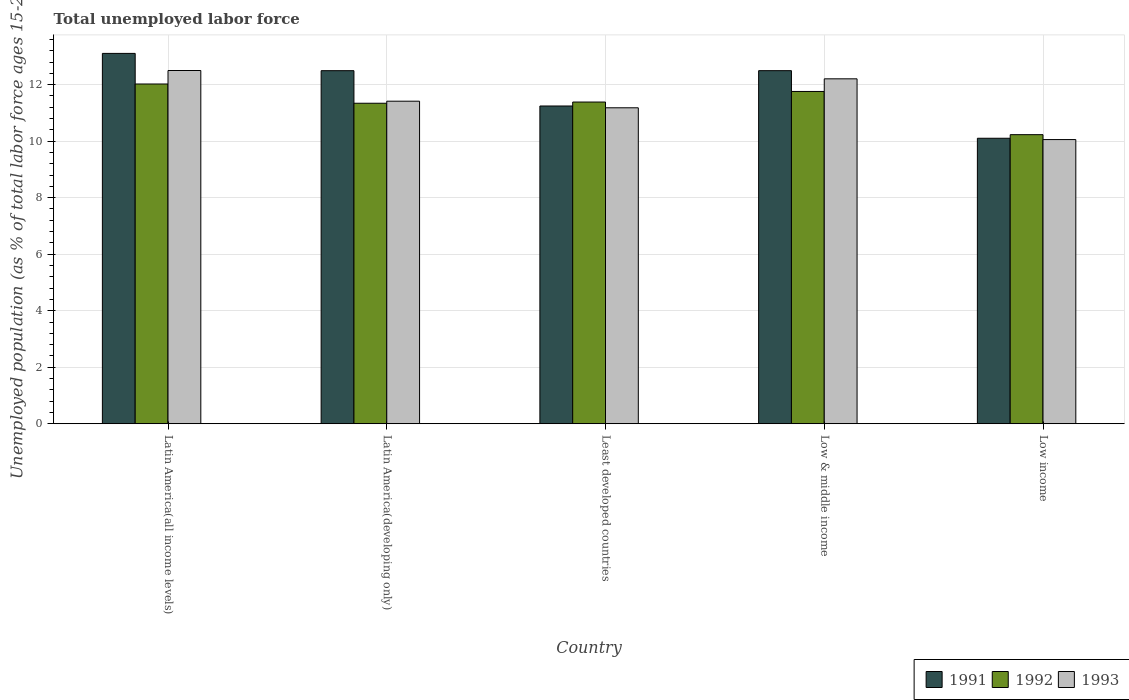How many groups of bars are there?
Keep it short and to the point. 5. Are the number of bars on each tick of the X-axis equal?
Your answer should be very brief. Yes. What is the label of the 1st group of bars from the left?
Provide a succinct answer. Latin America(all income levels). In how many cases, is the number of bars for a given country not equal to the number of legend labels?
Keep it short and to the point. 0. What is the percentage of unemployed population in in 1992 in Latin America(all income levels)?
Keep it short and to the point. 12.02. Across all countries, what is the maximum percentage of unemployed population in in 1991?
Provide a short and direct response. 13.11. Across all countries, what is the minimum percentage of unemployed population in in 1992?
Provide a succinct answer. 10.23. In which country was the percentage of unemployed population in in 1992 maximum?
Your response must be concise. Latin America(all income levels). What is the total percentage of unemployed population in in 1991 in the graph?
Ensure brevity in your answer.  59.45. What is the difference between the percentage of unemployed population in in 1993 in Latin America(all income levels) and that in Least developed countries?
Your response must be concise. 1.32. What is the difference between the percentage of unemployed population in in 1992 in Least developed countries and the percentage of unemployed population in in 1991 in Latin America(developing only)?
Your answer should be compact. -1.11. What is the average percentage of unemployed population in in 1992 per country?
Provide a succinct answer. 11.35. What is the difference between the percentage of unemployed population in of/in 1993 and percentage of unemployed population in of/in 1992 in Latin America(developing only)?
Your answer should be very brief. 0.07. What is the ratio of the percentage of unemployed population in in 1992 in Low & middle income to that in Low income?
Ensure brevity in your answer.  1.15. Is the percentage of unemployed population in in 1993 in Low & middle income less than that in Low income?
Provide a short and direct response. No. What is the difference between the highest and the second highest percentage of unemployed population in in 1992?
Offer a terse response. -0.37. What is the difference between the highest and the lowest percentage of unemployed population in in 1992?
Provide a succinct answer. 1.79. In how many countries, is the percentage of unemployed population in in 1991 greater than the average percentage of unemployed population in in 1991 taken over all countries?
Offer a very short reply. 3. Is the sum of the percentage of unemployed population in in 1993 in Latin America(all income levels) and Low income greater than the maximum percentage of unemployed population in in 1992 across all countries?
Your answer should be very brief. Yes. What does the 3rd bar from the left in Least developed countries represents?
Provide a succinct answer. 1993. What does the 3rd bar from the right in Low & middle income represents?
Provide a short and direct response. 1991. Is it the case that in every country, the sum of the percentage of unemployed population in in 1991 and percentage of unemployed population in in 1993 is greater than the percentage of unemployed population in in 1992?
Keep it short and to the point. Yes. Are all the bars in the graph horizontal?
Ensure brevity in your answer.  No. How many countries are there in the graph?
Your response must be concise. 5. What is the difference between two consecutive major ticks on the Y-axis?
Provide a succinct answer. 2. Are the values on the major ticks of Y-axis written in scientific E-notation?
Offer a very short reply. No. Does the graph contain any zero values?
Your response must be concise. No. Where does the legend appear in the graph?
Ensure brevity in your answer.  Bottom right. What is the title of the graph?
Ensure brevity in your answer.  Total unemployed labor force. What is the label or title of the Y-axis?
Give a very brief answer. Unemployed population (as % of total labor force ages 15-24). What is the Unemployed population (as % of total labor force ages 15-24) in 1991 in Latin America(all income levels)?
Offer a terse response. 13.11. What is the Unemployed population (as % of total labor force ages 15-24) in 1992 in Latin America(all income levels)?
Offer a very short reply. 12.02. What is the Unemployed population (as % of total labor force ages 15-24) of 1993 in Latin America(all income levels)?
Your answer should be very brief. 12.5. What is the Unemployed population (as % of total labor force ages 15-24) in 1991 in Latin America(developing only)?
Offer a terse response. 12.5. What is the Unemployed population (as % of total labor force ages 15-24) of 1992 in Latin America(developing only)?
Your answer should be compact. 11.34. What is the Unemployed population (as % of total labor force ages 15-24) in 1993 in Latin America(developing only)?
Keep it short and to the point. 11.42. What is the Unemployed population (as % of total labor force ages 15-24) in 1991 in Least developed countries?
Offer a very short reply. 11.25. What is the Unemployed population (as % of total labor force ages 15-24) in 1992 in Least developed countries?
Make the answer very short. 11.39. What is the Unemployed population (as % of total labor force ages 15-24) of 1993 in Least developed countries?
Offer a very short reply. 11.18. What is the Unemployed population (as % of total labor force ages 15-24) in 1991 in Low & middle income?
Provide a succinct answer. 12.5. What is the Unemployed population (as % of total labor force ages 15-24) in 1992 in Low & middle income?
Offer a very short reply. 11.76. What is the Unemployed population (as % of total labor force ages 15-24) of 1993 in Low & middle income?
Keep it short and to the point. 12.21. What is the Unemployed population (as % of total labor force ages 15-24) of 1991 in Low income?
Ensure brevity in your answer.  10.1. What is the Unemployed population (as % of total labor force ages 15-24) of 1992 in Low income?
Ensure brevity in your answer.  10.23. What is the Unemployed population (as % of total labor force ages 15-24) of 1993 in Low income?
Offer a very short reply. 10.06. Across all countries, what is the maximum Unemployed population (as % of total labor force ages 15-24) of 1991?
Make the answer very short. 13.11. Across all countries, what is the maximum Unemployed population (as % of total labor force ages 15-24) in 1992?
Keep it short and to the point. 12.02. Across all countries, what is the maximum Unemployed population (as % of total labor force ages 15-24) of 1993?
Make the answer very short. 12.5. Across all countries, what is the minimum Unemployed population (as % of total labor force ages 15-24) in 1991?
Your response must be concise. 10.1. Across all countries, what is the minimum Unemployed population (as % of total labor force ages 15-24) in 1992?
Give a very brief answer. 10.23. Across all countries, what is the minimum Unemployed population (as % of total labor force ages 15-24) of 1993?
Your answer should be very brief. 10.06. What is the total Unemployed population (as % of total labor force ages 15-24) of 1991 in the graph?
Your answer should be compact. 59.45. What is the total Unemployed population (as % of total labor force ages 15-24) in 1992 in the graph?
Give a very brief answer. 56.74. What is the total Unemployed population (as % of total labor force ages 15-24) of 1993 in the graph?
Your answer should be compact. 57.36. What is the difference between the Unemployed population (as % of total labor force ages 15-24) of 1991 in Latin America(all income levels) and that in Latin America(developing only)?
Your answer should be very brief. 0.61. What is the difference between the Unemployed population (as % of total labor force ages 15-24) in 1992 in Latin America(all income levels) and that in Latin America(developing only)?
Offer a very short reply. 0.68. What is the difference between the Unemployed population (as % of total labor force ages 15-24) of 1993 in Latin America(all income levels) and that in Latin America(developing only)?
Make the answer very short. 1.09. What is the difference between the Unemployed population (as % of total labor force ages 15-24) in 1991 in Latin America(all income levels) and that in Least developed countries?
Offer a very short reply. 1.86. What is the difference between the Unemployed population (as % of total labor force ages 15-24) in 1992 in Latin America(all income levels) and that in Least developed countries?
Your answer should be very brief. 0.64. What is the difference between the Unemployed population (as % of total labor force ages 15-24) in 1993 in Latin America(all income levels) and that in Least developed countries?
Provide a succinct answer. 1.32. What is the difference between the Unemployed population (as % of total labor force ages 15-24) of 1991 in Latin America(all income levels) and that in Low & middle income?
Provide a short and direct response. 0.61. What is the difference between the Unemployed population (as % of total labor force ages 15-24) of 1992 in Latin America(all income levels) and that in Low & middle income?
Your response must be concise. 0.26. What is the difference between the Unemployed population (as % of total labor force ages 15-24) in 1993 in Latin America(all income levels) and that in Low & middle income?
Ensure brevity in your answer.  0.29. What is the difference between the Unemployed population (as % of total labor force ages 15-24) in 1991 in Latin America(all income levels) and that in Low income?
Your answer should be very brief. 3. What is the difference between the Unemployed population (as % of total labor force ages 15-24) of 1992 in Latin America(all income levels) and that in Low income?
Make the answer very short. 1.79. What is the difference between the Unemployed population (as % of total labor force ages 15-24) of 1993 in Latin America(all income levels) and that in Low income?
Keep it short and to the point. 2.44. What is the difference between the Unemployed population (as % of total labor force ages 15-24) in 1991 in Latin America(developing only) and that in Least developed countries?
Offer a very short reply. 1.25. What is the difference between the Unemployed population (as % of total labor force ages 15-24) in 1992 in Latin America(developing only) and that in Least developed countries?
Offer a terse response. -0.04. What is the difference between the Unemployed population (as % of total labor force ages 15-24) in 1993 in Latin America(developing only) and that in Least developed countries?
Keep it short and to the point. 0.23. What is the difference between the Unemployed population (as % of total labor force ages 15-24) of 1991 in Latin America(developing only) and that in Low & middle income?
Offer a terse response. -0. What is the difference between the Unemployed population (as % of total labor force ages 15-24) of 1992 in Latin America(developing only) and that in Low & middle income?
Provide a succinct answer. -0.42. What is the difference between the Unemployed population (as % of total labor force ages 15-24) in 1993 in Latin America(developing only) and that in Low & middle income?
Give a very brief answer. -0.79. What is the difference between the Unemployed population (as % of total labor force ages 15-24) of 1991 in Latin America(developing only) and that in Low income?
Give a very brief answer. 2.39. What is the difference between the Unemployed population (as % of total labor force ages 15-24) of 1992 in Latin America(developing only) and that in Low income?
Keep it short and to the point. 1.11. What is the difference between the Unemployed population (as % of total labor force ages 15-24) of 1993 in Latin America(developing only) and that in Low income?
Ensure brevity in your answer.  1.36. What is the difference between the Unemployed population (as % of total labor force ages 15-24) of 1991 in Least developed countries and that in Low & middle income?
Offer a terse response. -1.25. What is the difference between the Unemployed population (as % of total labor force ages 15-24) in 1992 in Least developed countries and that in Low & middle income?
Your answer should be very brief. -0.37. What is the difference between the Unemployed population (as % of total labor force ages 15-24) in 1993 in Least developed countries and that in Low & middle income?
Offer a very short reply. -1.03. What is the difference between the Unemployed population (as % of total labor force ages 15-24) in 1991 in Least developed countries and that in Low income?
Provide a succinct answer. 1.14. What is the difference between the Unemployed population (as % of total labor force ages 15-24) of 1992 in Least developed countries and that in Low income?
Offer a very short reply. 1.15. What is the difference between the Unemployed population (as % of total labor force ages 15-24) in 1993 in Least developed countries and that in Low income?
Offer a terse response. 1.12. What is the difference between the Unemployed population (as % of total labor force ages 15-24) of 1991 in Low & middle income and that in Low income?
Offer a very short reply. 2.39. What is the difference between the Unemployed population (as % of total labor force ages 15-24) of 1992 in Low & middle income and that in Low income?
Keep it short and to the point. 1.53. What is the difference between the Unemployed population (as % of total labor force ages 15-24) in 1993 in Low & middle income and that in Low income?
Your answer should be very brief. 2.15. What is the difference between the Unemployed population (as % of total labor force ages 15-24) of 1991 in Latin America(all income levels) and the Unemployed population (as % of total labor force ages 15-24) of 1992 in Latin America(developing only)?
Provide a short and direct response. 1.76. What is the difference between the Unemployed population (as % of total labor force ages 15-24) of 1991 in Latin America(all income levels) and the Unemployed population (as % of total labor force ages 15-24) of 1993 in Latin America(developing only)?
Keep it short and to the point. 1.69. What is the difference between the Unemployed population (as % of total labor force ages 15-24) of 1992 in Latin America(all income levels) and the Unemployed population (as % of total labor force ages 15-24) of 1993 in Latin America(developing only)?
Keep it short and to the point. 0.61. What is the difference between the Unemployed population (as % of total labor force ages 15-24) in 1991 in Latin America(all income levels) and the Unemployed population (as % of total labor force ages 15-24) in 1992 in Least developed countries?
Your response must be concise. 1.72. What is the difference between the Unemployed population (as % of total labor force ages 15-24) in 1991 in Latin America(all income levels) and the Unemployed population (as % of total labor force ages 15-24) in 1993 in Least developed countries?
Make the answer very short. 1.93. What is the difference between the Unemployed population (as % of total labor force ages 15-24) of 1992 in Latin America(all income levels) and the Unemployed population (as % of total labor force ages 15-24) of 1993 in Least developed countries?
Your answer should be very brief. 0.84. What is the difference between the Unemployed population (as % of total labor force ages 15-24) of 1991 in Latin America(all income levels) and the Unemployed population (as % of total labor force ages 15-24) of 1992 in Low & middle income?
Ensure brevity in your answer.  1.35. What is the difference between the Unemployed population (as % of total labor force ages 15-24) in 1991 in Latin America(all income levels) and the Unemployed population (as % of total labor force ages 15-24) in 1993 in Low & middle income?
Provide a short and direct response. 0.9. What is the difference between the Unemployed population (as % of total labor force ages 15-24) in 1992 in Latin America(all income levels) and the Unemployed population (as % of total labor force ages 15-24) in 1993 in Low & middle income?
Make the answer very short. -0.18. What is the difference between the Unemployed population (as % of total labor force ages 15-24) of 1991 in Latin America(all income levels) and the Unemployed population (as % of total labor force ages 15-24) of 1992 in Low income?
Give a very brief answer. 2.88. What is the difference between the Unemployed population (as % of total labor force ages 15-24) in 1991 in Latin America(all income levels) and the Unemployed population (as % of total labor force ages 15-24) in 1993 in Low income?
Offer a very short reply. 3.05. What is the difference between the Unemployed population (as % of total labor force ages 15-24) in 1992 in Latin America(all income levels) and the Unemployed population (as % of total labor force ages 15-24) in 1993 in Low income?
Your answer should be compact. 1.97. What is the difference between the Unemployed population (as % of total labor force ages 15-24) in 1991 in Latin America(developing only) and the Unemployed population (as % of total labor force ages 15-24) in 1992 in Least developed countries?
Ensure brevity in your answer.  1.11. What is the difference between the Unemployed population (as % of total labor force ages 15-24) in 1991 in Latin America(developing only) and the Unemployed population (as % of total labor force ages 15-24) in 1993 in Least developed countries?
Offer a very short reply. 1.31. What is the difference between the Unemployed population (as % of total labor force ages 15-24) of 1992 in Latin America(developing only) and the Unemployed population (as % of total labor force ages 15-24) of 1993 in Least developed countries?
Provide a succinct answer. 0.16. What is the difference between the Unemployed population (as % of total labor force ages 15-24) of 1991 in Latin America(developing only) and the Unemployed population (as % of total labor force ages 15-24) of 1992 in Low & middle income?
Give a very brief answer. 0.74. What is the difference between the Unemployed population (as % of total labor force ages 15-24) in 1991 in Latin America(developing only) and the Unemployed population (as % of total labor force ages 15-24) in 1993 in Low & middle income?
Make the answer very short. 0.29. What is the difference between the Unemployed population (as % of total labor force ages 15-24) in 1992 in Latin America(developing only) and the Unemployed population (as % of total labor force ages 15-24) in 1993 in Low & middle income?
Your answer should be very brief. -0.86. What is the difference between the Unemployed population (as % of total labor force ages 15-24) in 1991 in Latin America(developing only) and the Unemployed population (as % of total labor force ages 15-24) in 1992 in Low income?
Provide a succinct answer. 2.26. What is the difference between the Unemployed population (as % of total labor force ages 15-24) of 1991 in Latin America(developing only) and the Unemployed population (as % of total labor force ages 15-24) of 1993 in Low income?
Offer a very short reply. 2.44. What is the difference between the Unemployed population (as % of total labor force ages 15-24) in 1992 in Latin America(developing only) and the Unemployed population (as % of total labor force ages 15-24) in 1993 in Low income?
Give a very brief answer. 1.29. What is the difference between the Unemployed population (as % of total labor force ages 15-24) of 1991 in Least developed countries and the Unemployed population (as % of total labor force ages 15-24) of 1992 in Low & middle income?
Provide a succinct answer. -0.51. What is the difference between the Unemployed population (as % of total labor force ages 15-24) of 1991 in Least developed countries and the Unemployed population (as % of total labor force ages 15-24) of 1993 in Low & middle income?
Provide a short and direct response. -0.96. What is the difference between the Unemployed population (as % of total labor force ages 15-24) of 1992 in Least developed countries and the Unemployed population (as % of total labor force ages 15-24) of 1993 in Low & middle income?
Make the answer very short. -0.82. What is the difference between the Unemployed population (as % of total labor force ages 15-24) of 1991 in Least developed countries and the Unemployed population (as % of total labor force ages 15-24) of 1992 in Low income?
Your answer should be compact. 1.01. What is the difference between the Unemployed population (as % of total labor force ages 15-24) of 1991 in Least developed countries and the Unemployed population (as % of total labor force ages 15-24) of 1993 in Low income?
Offer a very short reply. 1.19. What is the difference between the Unemployed population (as % of total labor force ages 15-24) of 1992 in Least developed countries and the Unemployed population (as % of total labor force ages 15-24) of 1993 in Low income?
Offer a terse response. 1.33. What is the difference between the Unemployed population (as % of total labor force ages 15-24) of 1991 in Low & middle income and the Unemployed population (as % of total labor force ages 15-24) of 1992 in Low income?
Provide a succinct answer. 2.27. What is the difference between the Unemployed population (as % of total labor force ages 15-24) of 1991 in Low & middle income and the Unemployed population (as % of total labor force ages 15-24) of 1993 in Low income?
Your answer should be compact. 2.44. What is the difference between the Unemployed population (as % of total labor force ages 15-24) in 1992 in Low & middle income and the Unemployed population (as % of total labor force ages 15-24) in 1993 in Low income?
Keep it short and to the point. 1.7. What is the average Unemployed population (as % of total labor force ages 15-24) in 1991 per country?
Keep it short and to the point. 11.89. What is the average Unemployed population (as % of total labor force ages 15-24) of 1992 per country?
Your response must be concise. 11.35. What is the average Unemployed population (as % of total labor force ages 15-24) in 1993 per country?
Ensure brevity in your answer.  11.47. What is the difference between the Unemployed population (as % of total labor force ages 15-24) in 1991 and Unemployed population (as % of total labor force ages 15-24) in 1992 in Latin America(all income levels)?
Make the answer very short. 1.08. What is the difference between the Unemployed population (as % of total labor force ages 15-24) of 1991 and Unemployed population (as % of total labor force ages 15-24) of 1993 in Latin America(all income levels)?
Offer a terse response. 0.61. What is the difference between the Unemployed population (as % of total labor force ages 15-24) in 1992 and Unemployed population (as % of total labor force ages 15-24) in 1993 in Latin America(all income levels)?
Keep it short and to the point. -0.48. What is the difference between the Unemployed population (as % of total labor force ages 15-24) in 1991 and Unemployed population (as % of total labor force ages 15-24) in 1992 in Latin America(developing only)?
Keep it short and to the point. 1.15. What is the difference between the Unemployed population (as % of total labor force ages 15-24) in 1991 and Unemployed population (as % of total labor force ages 15-24) in 1993 in Latin America(developing only)?
Provide a succinct answer. 1.08. What is the difference between the Unemployed population (as % of total labor force ages 15-24) of 1992 and Unemployed population (as % of total labor force ages 15-24) of 1993 in Latin America(developing only)?
Provide a succinct answer. -0.07. What is the difference between the Unemployed population (as % of total labor force ages 15-24) of 1991 and Unemployed population (as % of total labor force ages 15-24) of 1992 in Least developed countries?
Offer a very short reply. -0.14. What is the difference between the Unemployed population (as % of total labor force ages 15-24) in 1991 and Unemployed population (as % of total labor force ages 15-24) in 1993 in Least developed countries?
Give a very brief answer. 0.06. What is the difference between the Unemployed population (as % of total labor force ages 15-24) in 1992 and Unemployed population (as % of total labor force ages 15-24) in 1993 in Least developed countries?
Offer a very short reply. 0.2. What is the difference between the Unemployed population (as % of total labor force ages 15-24) of 1991 and Unemployed population (as % of total labor force ages 15-24) of 1992 in Low & middle income?
Your response must be concise. 0.74. What is the difference between the Unemployed population (as % of total labor force ages 15-24) of 1991 and Unemployed population (as % of total labor force ages 15-24) of 1993 in Low & middle income?
Offer a terse response. 0.29. What is the difference between the Unemployed population (as % of total labor force ages 15-24) in 1992 and Unemployed population (as % of total labor force ages 15-24) in 1993 in Low & middle income?
Keep it short and to the point. -0.45. What is the difference between the Unemployed population (as % of total labor force ages 15-24) of 1991 and Unemployed population (as % of total labor force ages 15-24) of 1992 in Low income?
Provide a short and direct response. -0.13. What is the difference between the Unemployed population (as % of total labor force ages 15-24) of 1991 and Unemployed population (as % of total labor force ages 15-24) of 1993 in Low income?
Your answer should be compact. 0.05. What is the difference between the Unemployed population (as % of total labor force ages 15-24) in 1992 and Unemployed population (as % of total labor force ages 15-24) in 1993 in Low income?
Your answer should be compact. 0.17. What is the ratio of the Unemployed population (as % of total labor force ages 15-24) of 1991 in Latin America(all income levels) to that in Latin America(developing only)?
Offer a very short reply. 1.05. What is the ratio of the Unemployed population (as % of total labor force ages 15-24) of 1992 in Latin America(all income levels) to that in Latin America(developing only)?
Offer a very short reply. 1.06. What is the ratio of the Unemployed population (as % of total labor force ages 15-24) of 1993 in Latin America(all income levels) to that in Latin America(developing only)?
Ensure brevity in your answer.  1.1. What is the ratio of the Unemployed population (as % of total labor force ages 15-24) in 1991 in Latin America(all income levels) to that in Least developed countries?
Give a very brief answer. 1.17. What is the ratio of the Unemployed population (as % of total labor force ages 15-24) in 1992 in Latin America(all income levels) to that in Least developed countries?
Ensure brevity in your answer.  1.06. What is the ratio of the Unemployed population (as % of total labor force ages 15-24) in 1993 in Latin America(all income levels) to that in Least developed countries?
Keep it short and to the point. 1.12. What is the ratio of the Unemployed population (as % of total labor force ages 15-24) in 1991 in Latin America(all income levels) to that in Low & middle income?
Your answer should be compact. 1.05. What is the ratio of the Unemployed population (as % of total labor force ages 15-24) in 1992 in Latin America(all income levels) to that in Low & middle income?
Your response must be concise. 1.02. What is the ratio of the Unemployed population (as % of total labor force ages 15-24) of 1993 in Latin America(all income levels) to that in Low & middle income?
Keep it short and to the point. 1.02. What is the ratio of the Unemployed population (as % of total labor force ages 15-24) in 1991 in Latin America(all income levels) to that in Low income?
Give a very brief answer. 1.3. What is the ratio of the Unemployed population (as % of total labor force ages 15-24) of 1992 in Latin America(all income levels) to that in Low income?
Provide a succinct answer. 1.18. What is the ratio of the Unemployed population (as % of total labor force ages 15-24) of 1993 in Latin America(all income levels) to that in Low income?
Keep it short and to the point. 1.24. What is the ratio of the Unemployed population (as % of total labor force ages 15-24) in 1991 in Latin America(developing only) to that in Least developed countries?
Keep it short and to the point. 1.11. What is the ratio of the Unemployed population (as % of total labor force ages 15-24) of 1993 in Latin America(developing only) to that in Least developed countries?
Provide a succinct answer. 1.02. What is the ratio of the Unemployed population (as % of total labor force ages 15-24) of 1991 in Latin America(developing only) to that in Low & middle income?
Offer a terse response. 1. What is the ratio of the Unemployed population (as % of total labor force ages 15-24) of 1992 in Latin America(developing only) to that in Low & middle income?
Keep it short and to the point. 0.96. What is the ratio of the Unemployed population (as % of total labor force ages 15-24) of 1993 in Latin America(developing only) to that in Low & middle income?
Offer a very short reply. 0.94. What is the ratio of the Unemployed population (as % of total labor force ages 15-24) of 1991 in Latin America(developing only) to that in Low income?
Keep it short and to the point. 1.24. What is the ratio of the Unemployed population (as % of total labor force ages 15-24) in 1992 in Latin America(developing only) to that in Low income?
Offer a terse response. 1.11. What is the ratio of the Unemployed population (as % of total labor force ages 15-24) in 1993 in Latin America(developing only) to that in Low income?
Your answer should be very brief. 1.14. What is the ratio of the Unemployed population (as % of total labor force ages 15-24) of 1991 in Least developed countries to that in Low & middle income?
Offer a terse response. 0.9. What is the ratio of the Unemployed population (as % of total labor force ages 15-24) of 1992 in Least developed countries to that in Low & middle income?
Your answer should be very brief. 0.97. What is the ratio of the Unemployed population (as % of total labor force ages 15-24) in 1993 in Least developed countries to that in Low & middle income?
Provide a succinct answer. 0.92. What is the ratio of the Unemployed population (as % of total labor force ages 15-24) in 1991 in Least developed countries to that in Low income?
Your answer should be compact. 1.11. What is the ratio of the Unemployed population (as % of total labor force ages 15-24) in 1992 in Least developed countries to that in Low income?
Provide a succinct answer. 1.11. What is the ratio of the Unemployed population (as % of total labor force ages 15-24) in 1993 in Least developed countries to that in Low income?
Offer a terse response. 1.11. What is the ratio of the Unemployed population (as % of total labor force ages 15-24) in 1991 in Low & middle income to that in Low income?
Offer a very short reply. 1.24. What is the ratio of the Unemployed population (as % of total labor force ages 15-24) in 1992 in Low & middle income to that in Low income?
Make the answer very short. 1.15. What is the ratio of the Unemployed population (as % of total labor force ages 15-24) in 1993 in Low & middle income to that in Low income?
Your answer should be compact. 1.21. What is the difference between the highest and the second highest Unemployed population (as % of total labor force ages 15-24) in 1991?
Your answer should be very brief. 0.61. What is the difference between the highest and the second highest Unemployed population (as % of total labor force ages 15-24) of 1992?
Ensure brevity in your answer.  0.26. What is the difference between the highest and the second highest Unemployed population (as % of total labor force ages 15-24) in 1993?
Your response must be concise. 0.29. What is the difference between the highest and the lowest Unemployed population (as % of total labor force ages 15-24) of 1991?
Your answer should be compact. 3. What is the difference between the highest and the lowest Unemployed population (as % of total labor force ages 15-24) of 1992?
Provide a short and direct response. 1.79. What is the difference between the highest and the lowest Unemployed population (as % of total labor force ages 15-24) of 1993?
Your answer should be very brief. 2.44. 